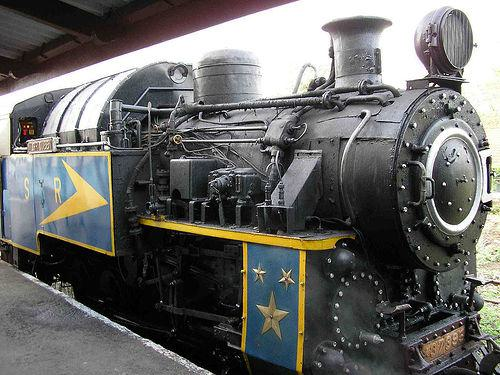Would there be a train in the image once the train has been removed from the scene? Once the train is removed from the image, it would no longer be visible; hence, there wouldn't be a train present in the scene. 